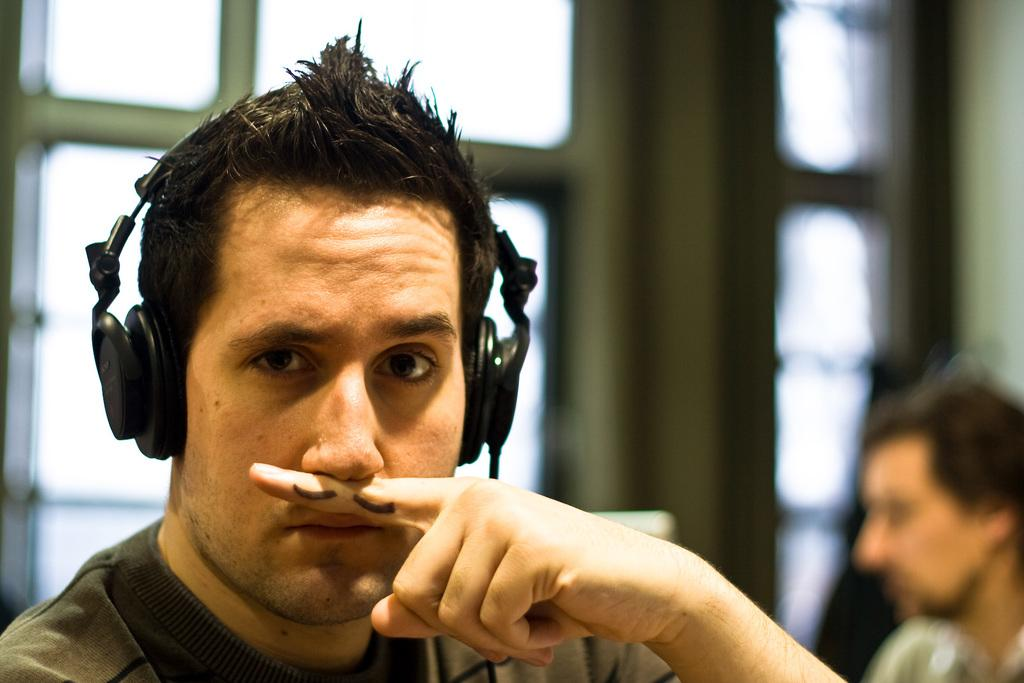What is the man in the image wearing on his head? The man in the image is wearing a headset. How would you describe the background of the image? The background of the image is blurry. Can you see any other people in the image? Yes, there is a person visible in the background. What is present in the background that might provide a view of the outside? There is a window in the background. What type of kiss is the man giving to the tank in the image? There is no tank present in the image, and therefore no kiss can be observed. 